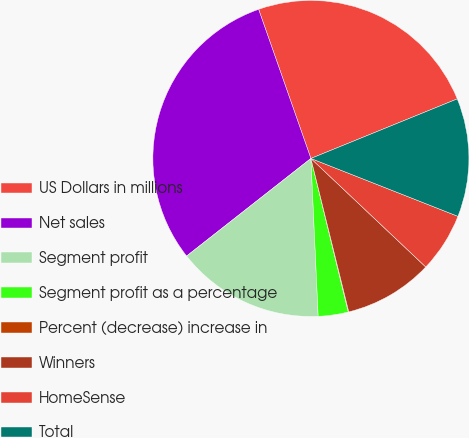<chart> <loc_0><loc_0><loc_500><loc_500><pie_chart><fcel>US Dollars in millions<fcel>Net sales<fcel>Segment profit<fcel>Segment profit as a percentage<fcel>Percent (decrease) increase in<fcel>Winners<fcel>HomeSense<fcel>Total<nl><fcel>24.22%<fcel>30.23%<fcel>15.14%<fcel>3.07%<fcel>0.05%<fcel>9.1%<fcel>6.08%<fcel>12.12%<nl></chart> 